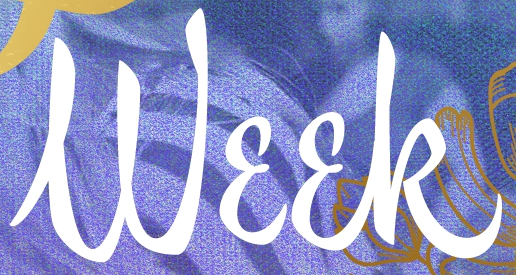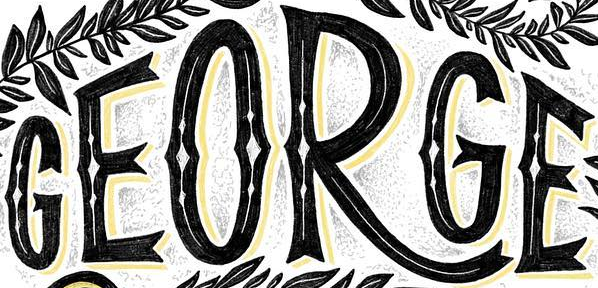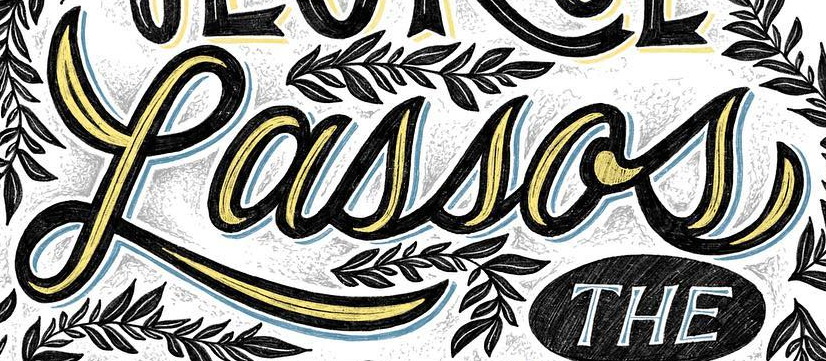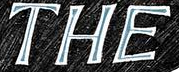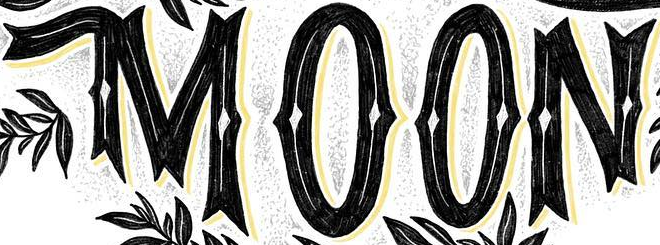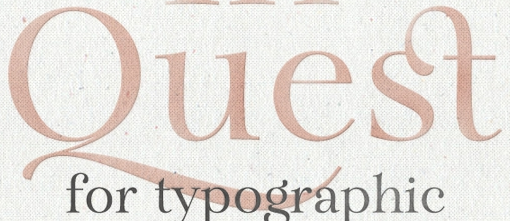Transcribe the words shown in these images in order, separated by a semicolon. Week; GEORGE; Lassos; THE; MOON; Quest 